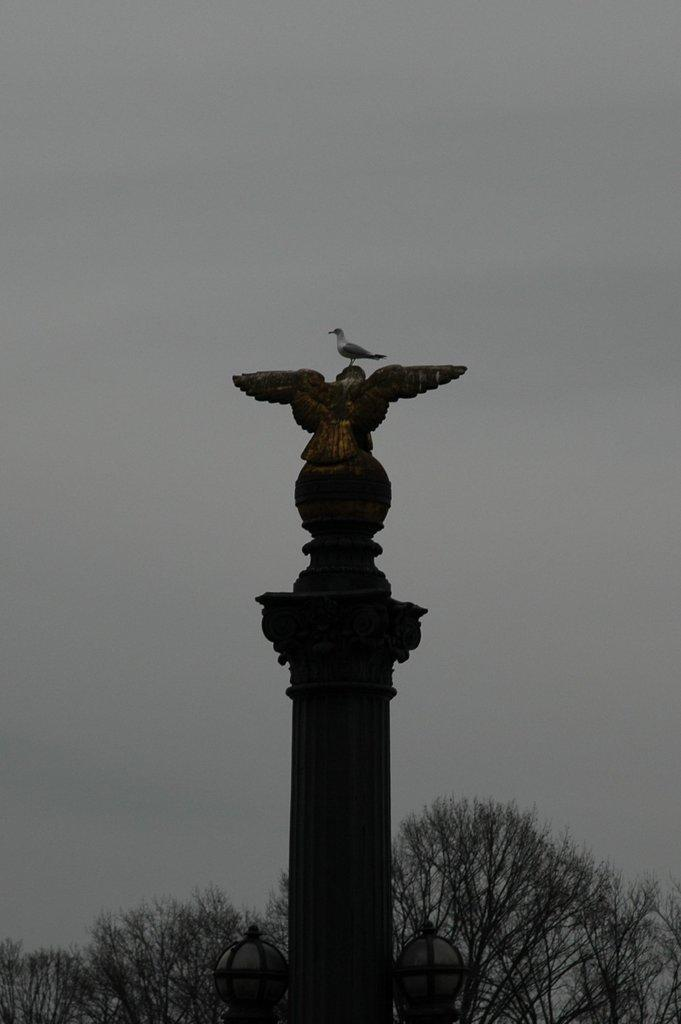What is on the head of the bird statue in the image? There is a bird on the head of the bird statue in the image. Where is the bird statue located? The bird statue is on a pole. What can be seen in the background of the image? There are trees and clouds in the sky in the background of the image. How does the bird statue answer the phone in the image? The bird statue does not answer a phone in the image; it is a statue and cannot perform actions like answering a phone. 